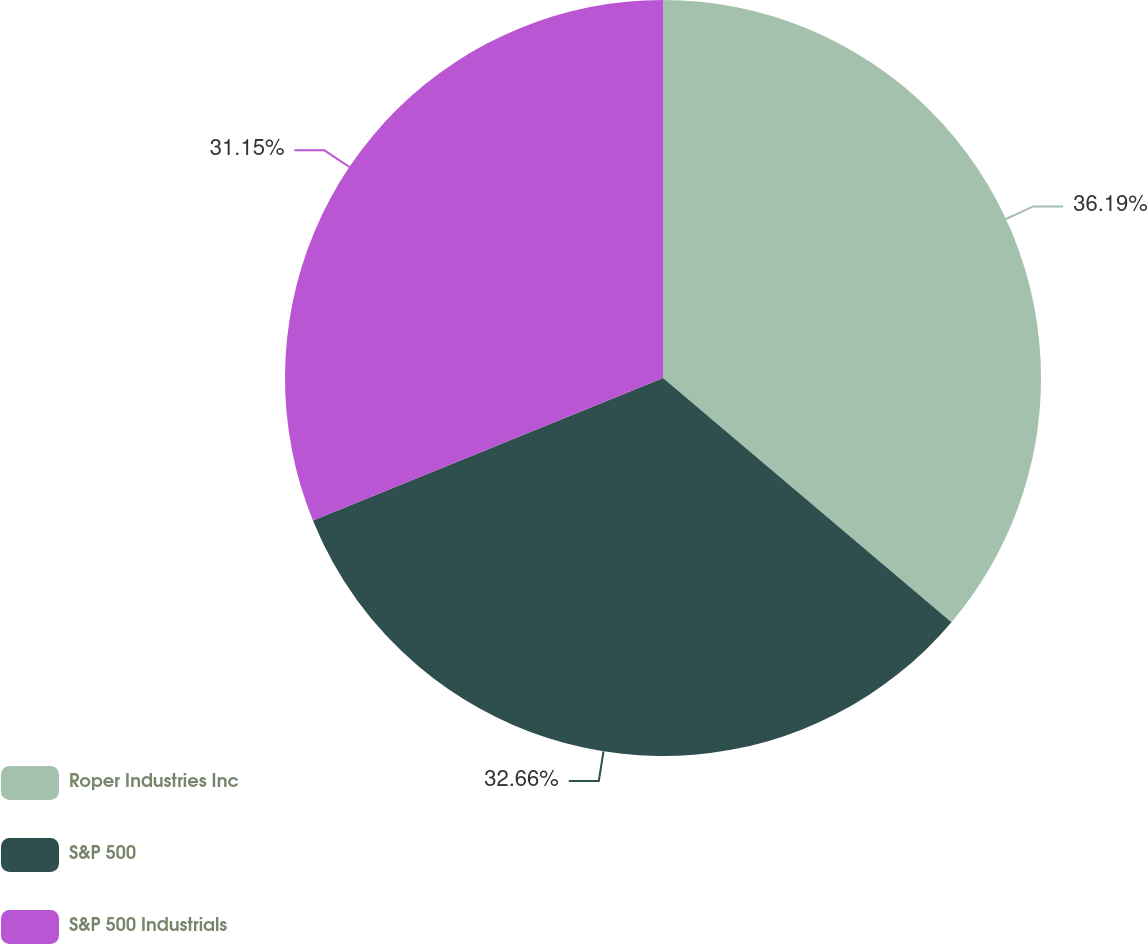Convert chart to OTSL. <chart><loc_0><loc_0><loc_500><loc_500><pie_chart><fcel>Roper Industries Inc<fcel>S&P 500<fcel>S&P 500 Industrials<nl><fcel>36.18%<fcel>32.66%<fcel>31.15%<nl></chart> 